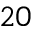<formula> <loc_0><loc_0><loc_500><loc_500>2 0</formula> 